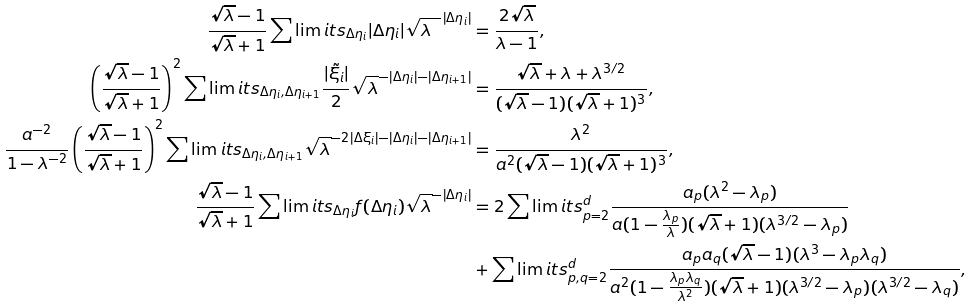<formula> <loc_0><loc_0><loc_500><loc_500>\frac { \sqrt { \lambda } - 1 } { \sqrt { \lambda } + 1 } \sum \lim i t s _ { \Delta \eta _ { i } } | \Delta \eta _ { i } | \sqrt { \lambda } ^ { - | \Delta \eta _ { i } | } & = \frac { 2 \sqrt { \lambda } } { \lambda - 1 } , \\ \left ( \frac { \sqrt { \lambda } - 1 } { \sqrt { \lambda } + 1 } \right ) ^ { 2 } \sum \lim i t s _ { \Delta \eta _ { i } , \Delta \eta _ { i + 1 } } \frac { | \tilde { \xi _ { i } } | } { 2 } \sqrt { \lambda } ^ { - | \Delta \eta _ { i } | - | \Delta \eta _ { i + 1 } | } & = \frac { \sqrt { \lambda } + \lambda + \lambda ^ { 3 / 2 } } { ( \sqrt { \lambda } - 1 ) ( \sqrt { \lambda } + 1 ) ^ { 3 } } , \\ \frac { a ^ { - 2 } } { 1 - \lambda ^ { - 2 } } \left ( \frac { \sqrt { \lambda } - 1 } { \sqrt { \lambda } + 1 } \right ) ^ { 2 } \sum \lim i t s _ { \Delta \eta _ { i } , \Delta \eta _ { i + 1 } } \sqrt { \lambda } ^ { - 2 | \Delta \xi _ { i } | - | \Delta \eta _ { i } | - | \Delta \eta _ { i + 1 } | } & = \frac { \lambda ^ { 2 } } { a ^ { 2 } ( \sqrt { \lambda } - 1 ) ( \sqrt { \lambda } + 1 ) ^ { 3 } } , \\ \frac { \sqrt { \lambda } - 1 } { \sqrt { \lambda } + 1 } \sum \lim i t s _ { \Delta \eta _ { i } } f ( \Delta \eta _ { i } ) \sqrt { \lambda } ^ { - | \Delta \eta _ { i } | } & = 2 \sum \lim i t s _ { p = 2 } ^ { d } \frac { a _ { p } ( \lambda ^ { 2 } - \lambda _ { p } ) } { a ( 1 - \frac { \lambda _ { p } } { \lambda } ) ( \sqrt { \lambda } + 1 ) ( \lambda ^ { 3 / 2 } - \lambda _ { p } ) } \\ & + \sum \lim i t s _ { p , q = 2 } ^ { d } \frac { a _ { p } a _ { q } ( \sqrt { \lambda } - 1 ) ( \lambda ^ { 3 } - \lambda _ { p } \lambda _ { q } ) } { a ^ { 2 } ( 1 - \frac { \lambda _ { p } \lambda _ { q } } { \lambda ^ { 2 } } ) ( \sqrt { \lambda } + 1 ) ( \lambda ^ { 3 / 2 } - \lambda _ { p } ) ( \lambda ^ { 3 / 2 } - \lambda _ { q } ) } ,</formula> 